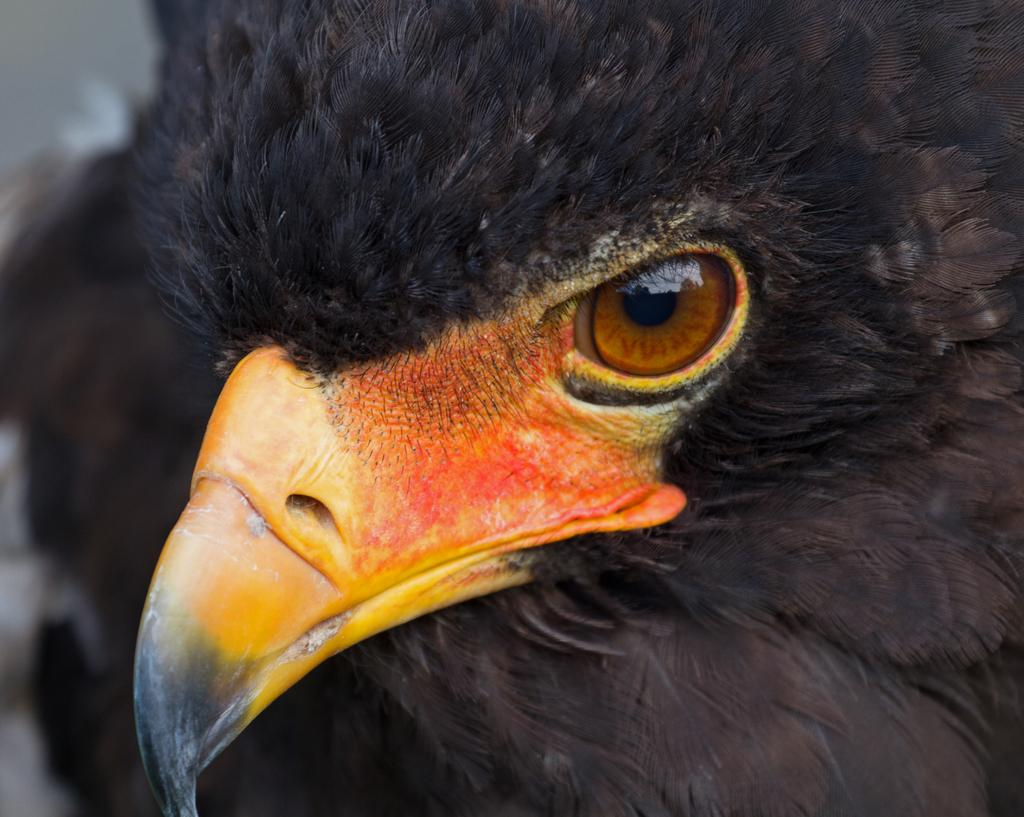What type of animal is present in the image? There is a bird in the image. What is the color of the bird? The bird is black in color. What can be observed about the bird's nose? The bird's nose is yellow, orange, and black. Are the bird's eyes visible in the image? Yes, the bird's eyes are visible in the image. Can the bird's nose be seen in the image? Yes, the bird's nose is visible in the image. What type of cactus is present in the image? There is no cactus present in the image; it features a bird. What religious symbol can be seen in the image? There is no religious symbol present in the image; it features a bird. 